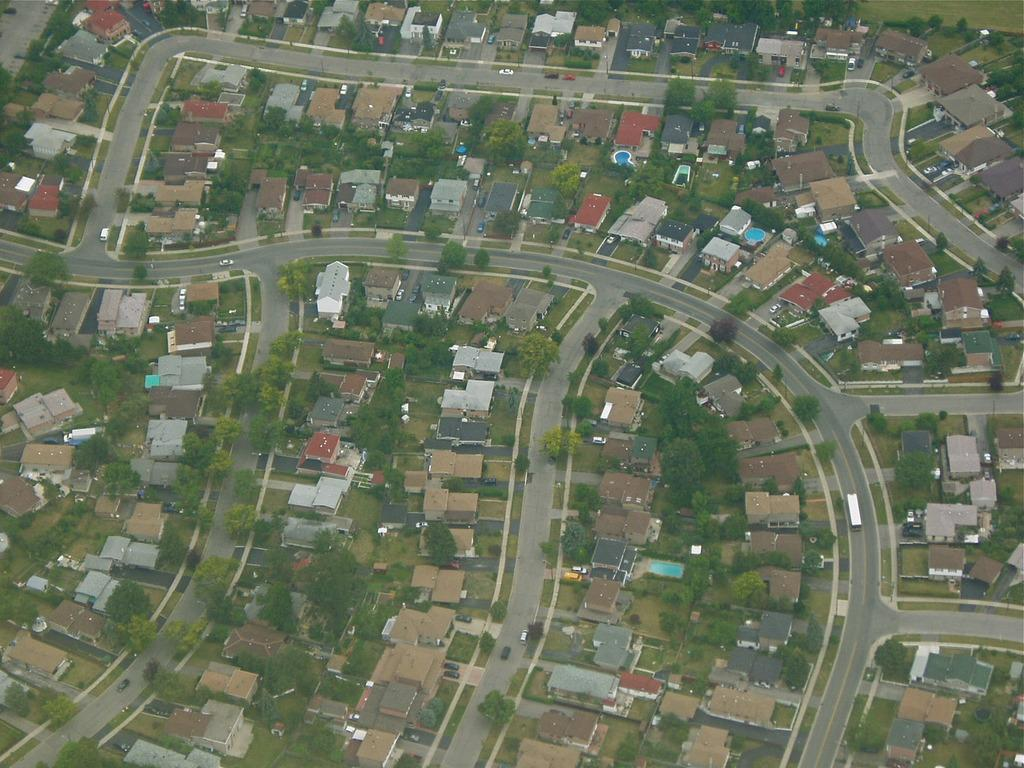What perspective is used to view the scene in the image? The image shows a top view of the scene. What types of structures can be seen in the image? There are buildings and houses in the image. What natural elements are present in the image? There are trees, plants, and grass in the image. What man-made elements are present in the image? There are roads and vehicles in the image. What type of spark can be seen coming from the finger of the person in the image? There is no person present in the image, and therefore no spark or finger can be observed. 